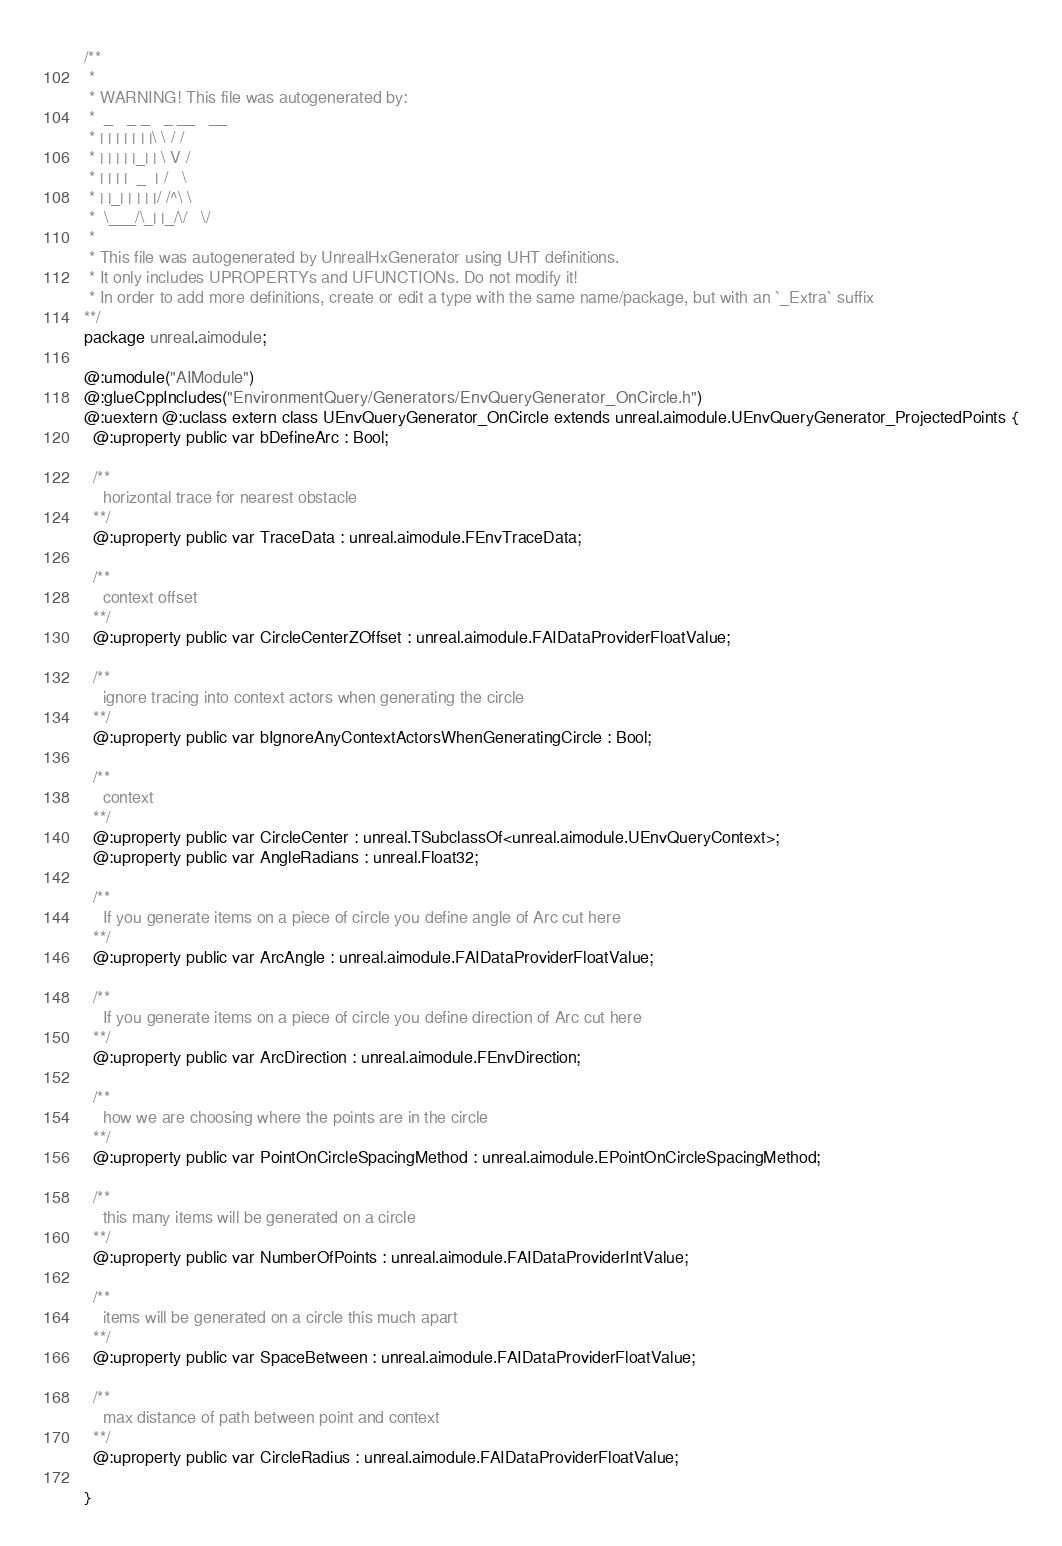Convert code to text. <code><loc_0><loc_0><loc_500><loc_500><_Haxe_>/**
 * 
 * WARNING! This file was autogenerated by: 
 *  _   _ _   _ __   __ 
 * | | | | | | |\ \ / / 
 * | | | | |_| | \ V /  
 * | | | |  _  | /   \  
 * | |_| | | | |/ /^\ \ 
 *  \___/\_| |_/\/   \/ 
 * 
 * This file was autogenerated by UnrealHxGenerator using UHT definitions.
 * It only includes UPROPERTYs and UFUNCTIONs. Do not modify it!
 * In order to add more definitions, create or edit a type with the same name/package, but with an `_Extra` suffix
**/
package unreal.aimodule;

@:umodule("AIModule")
@:glueCppIncludes("EnvironmentQuery/Generators/EnvQueryGenerator_OnCircle.h")
@:uextern @:uclass extern class UEnvQueryGenerator_OnCircle extends unreal.aimodule.UEnvQueryGenerator_ProjectedPoints {
  @:uproperty public var bDefineArc : Bool;
  
  /**
    horizontal trace for nearest obstacle
  **/
  @:uproperty public var TraceData : unreal.aimodule.FEnvTraceData;
  
  /**
    context offset
  **/
  @:uproperty public var CircleCenterZOffset : unreal.aimodule.FAIDataProviderFloatValue;
  
  /**
    ignore tracing into context actors when generating the circle
  **/
  @:uproperty public var bIgnoreAnyContextActorsWhenGeneratingCircle : Bool;
  
  /**
    context
  **/
  @:uproperty public var CircleCenter : unreal.TSubclassOf<unreal.aimodule.UEnvQueryContext>;
  @:uproperty public var AngleRadians : unreal.Float32;
  
  /**
    If you generate items on a piece of circle you define angle of Arc cut here
  **/
  @:uproperty public var ArcAngle : unreal.aimodule.FAIDataProviderFloatValue;
  
  /**
    If you generate items on a piece of circle you define direction of Arc cut here
  **/
  @:uproperty public var ArcDirection : unreal.aimodule.FEnvDirection;
  
  /**
    how we are choosing where the points are in the circle
  **/
  @:uproperty public var PointOnCircleSpacingMethod : unreal.aimodule.EPointOnCircleSpacingMethod;
  
  /**
    this many items will be generated on a circle
  **/
  @:uproperty public var NumberOfPoints : unreal.aimodule.FAIDataProviderIntValue;
  
  /**
    items will be generated on a circle this much apart
  **/
  @:uproperty public var SpaceBetween : unreal.aimodule.FAIDataProviderFloatValue;
  
  /**
    max distance of path between point and context
  **/
  @:uproperty public var CircleRadius : unreal.aimodule.FAIDataProviderFloatValue;
  
}
</code> 